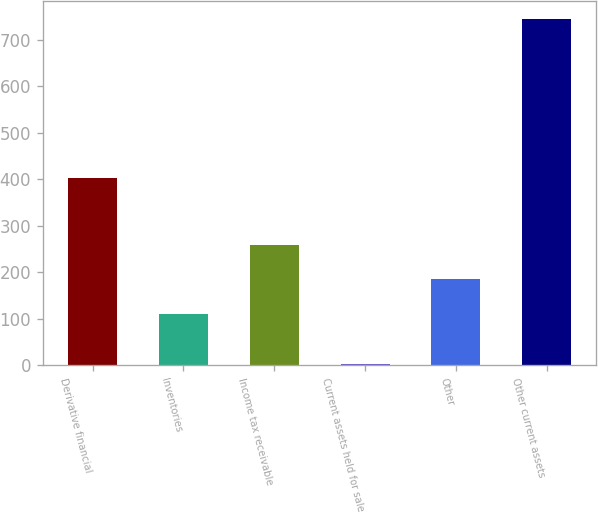Convert chart. <chart><loc_0><loc_0><loc_500><loc_500><bar_chart><fcel>Derivative financial<fcel>Inventories<fcel>Income tax receivable<fcel>Current assets held for sale<fcel>Other<fcel>Other current assets<nl><fcel>403<fcel>110<fcel>258.6<fcel>3<fcel>184.3<fcel>746<nl></chart> 